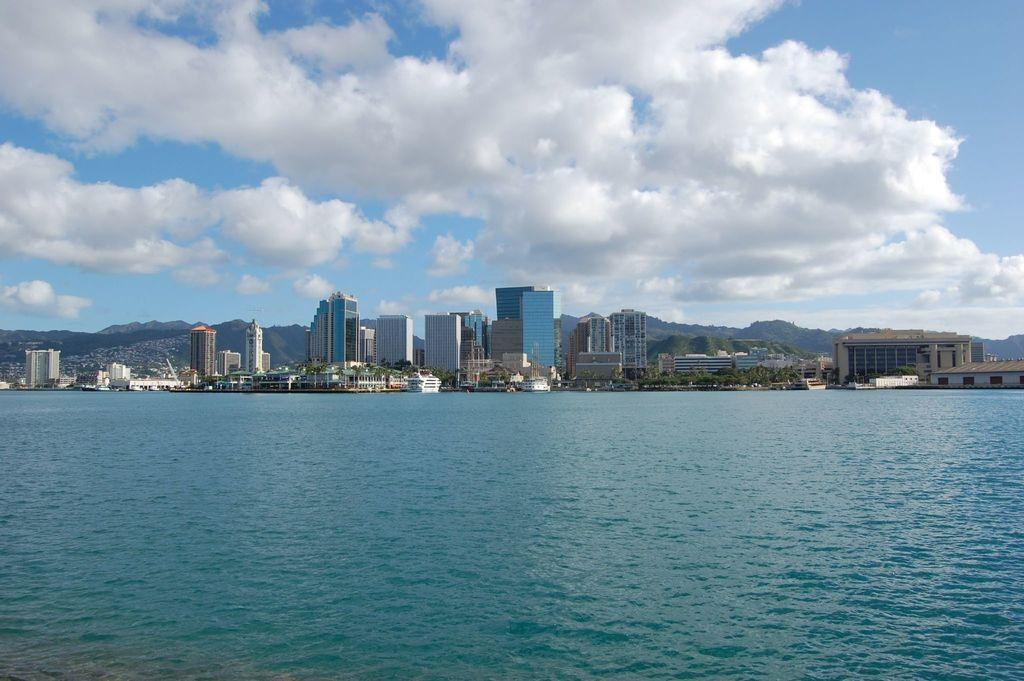What is the primary element visible in the image? There is water in the image. What can be seen in the distance behind the water? There are buildings, trees, hills, and the sky visible in the background of the image. What is the condition of the sky in the image? Clouds are present in the sky. What type of ring can be seen on the hand of the maid in the image? There is no maid or ring present in the image. How does the person in control of the water manipulate it in the image? There is no person in control of the water in the image; it is a natural body of water. 